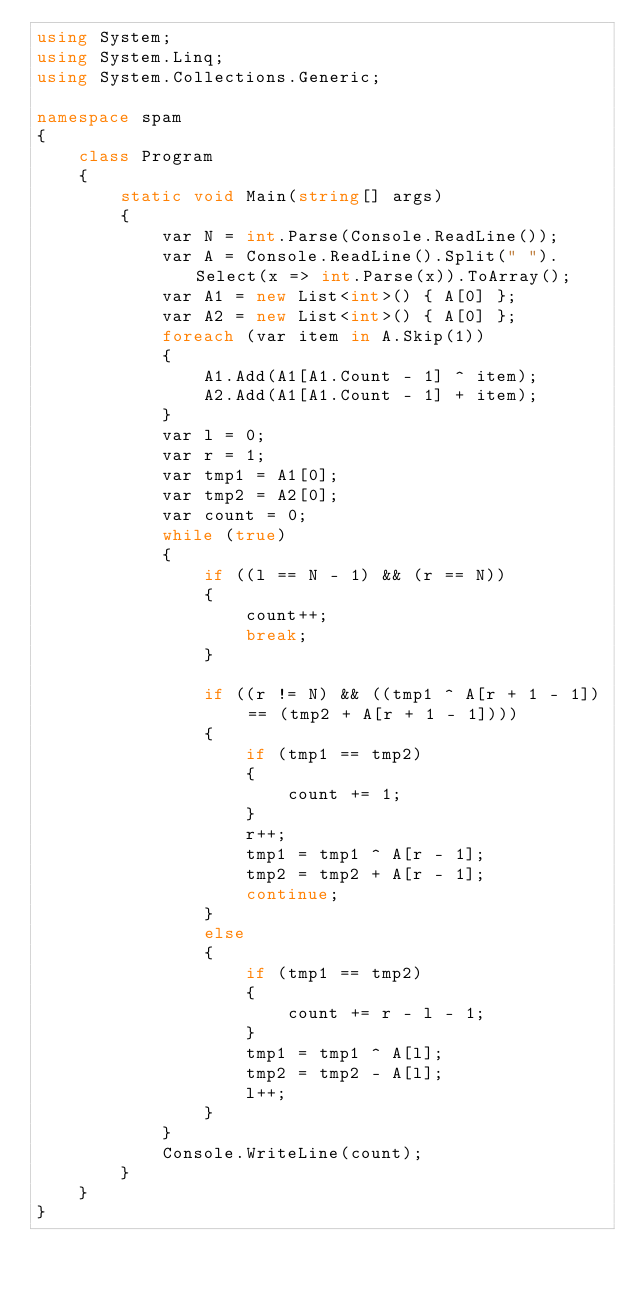Convert code to text. <code><loc_0><loc_0><loc_500><loc_500><_C#_>using System;
using System.Linq;
using System.Collections.Generic;

namespace spam
{
    class Program
    {
        static void Main(string[] args)
        {
            var N = int.Parse(Console.ReadLine());
            var A = Console.ReadLine().Split(" ").Select(x => int.Parse(x)).ToArray();
            var A1 = new List<int>() { A[0] };
            var A2 = new List<int>() { A[0] };
            foreach (var item in A.Skip(1))
            {
                A1.Add(A1[A1.Count - 1] ^ item);
                A2.Add(A1[A1.Count - 1] + item);
            }
            var l = 0;
            var r = 1;
            var tmp1 = A1[0];
            var tmp2 = A2[0];
            var count = 0;
            while (true)
            {
                if ((l == N - 1) && (r == N))
                {
                    count++;
                    break;
                }

                if ((r != N) && ((tmp1 ^ A[r + 1 - 1]) == (tmp2 + A[r + 1 - 1])))
                {
                    if (tmp1 == tmp2)
                    {
                        count += 1;
                    }
                    r++;
                    tmp1 = tmp1 ^ A[r - 1];
                    tmp2 = tmp2 + A[r - 1];
                    continue;
                }
                else
                {
                    if (tmp1 == tmp2)
                    {
                        count += r - l - 1;
                    }
                    tmp1 = tmp1 ^ A[l];
                    tmp2 = tmp2 - A[l];
                    l++;
                }
            }
            Console.WriteLine(count);
        }
    }
}
</code> 